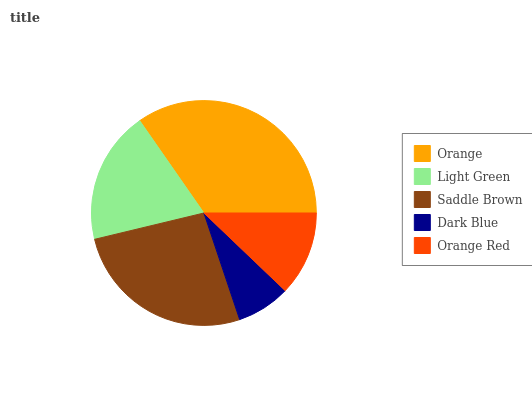Is Dark Blue the minimum?
Answer yes or no. Yes. Is Orange the maximum?
Answer yes or no. Yes. Is Light Green the minimum?
Answer yes or no. No. Is Light Green the maximum?
Answer yes or no. No. Is Orange greater than Light Green?
Answer yes or no. Yes. Is Light Green less than Orange?
Answer yes or no. Yes. Is Light Green greater than Orange?
Answer yes or no. No. Is Orange less than Light Green?
Answer yes or no. No. Is Light Green the high median?
Answer yes or no. Yes. Is Light Green the low median?
Answer yes or no. Yes. Is Orange Red the high median?
Answer yes or no. No. Is Orange the low median?
Answer yes or no. No. 